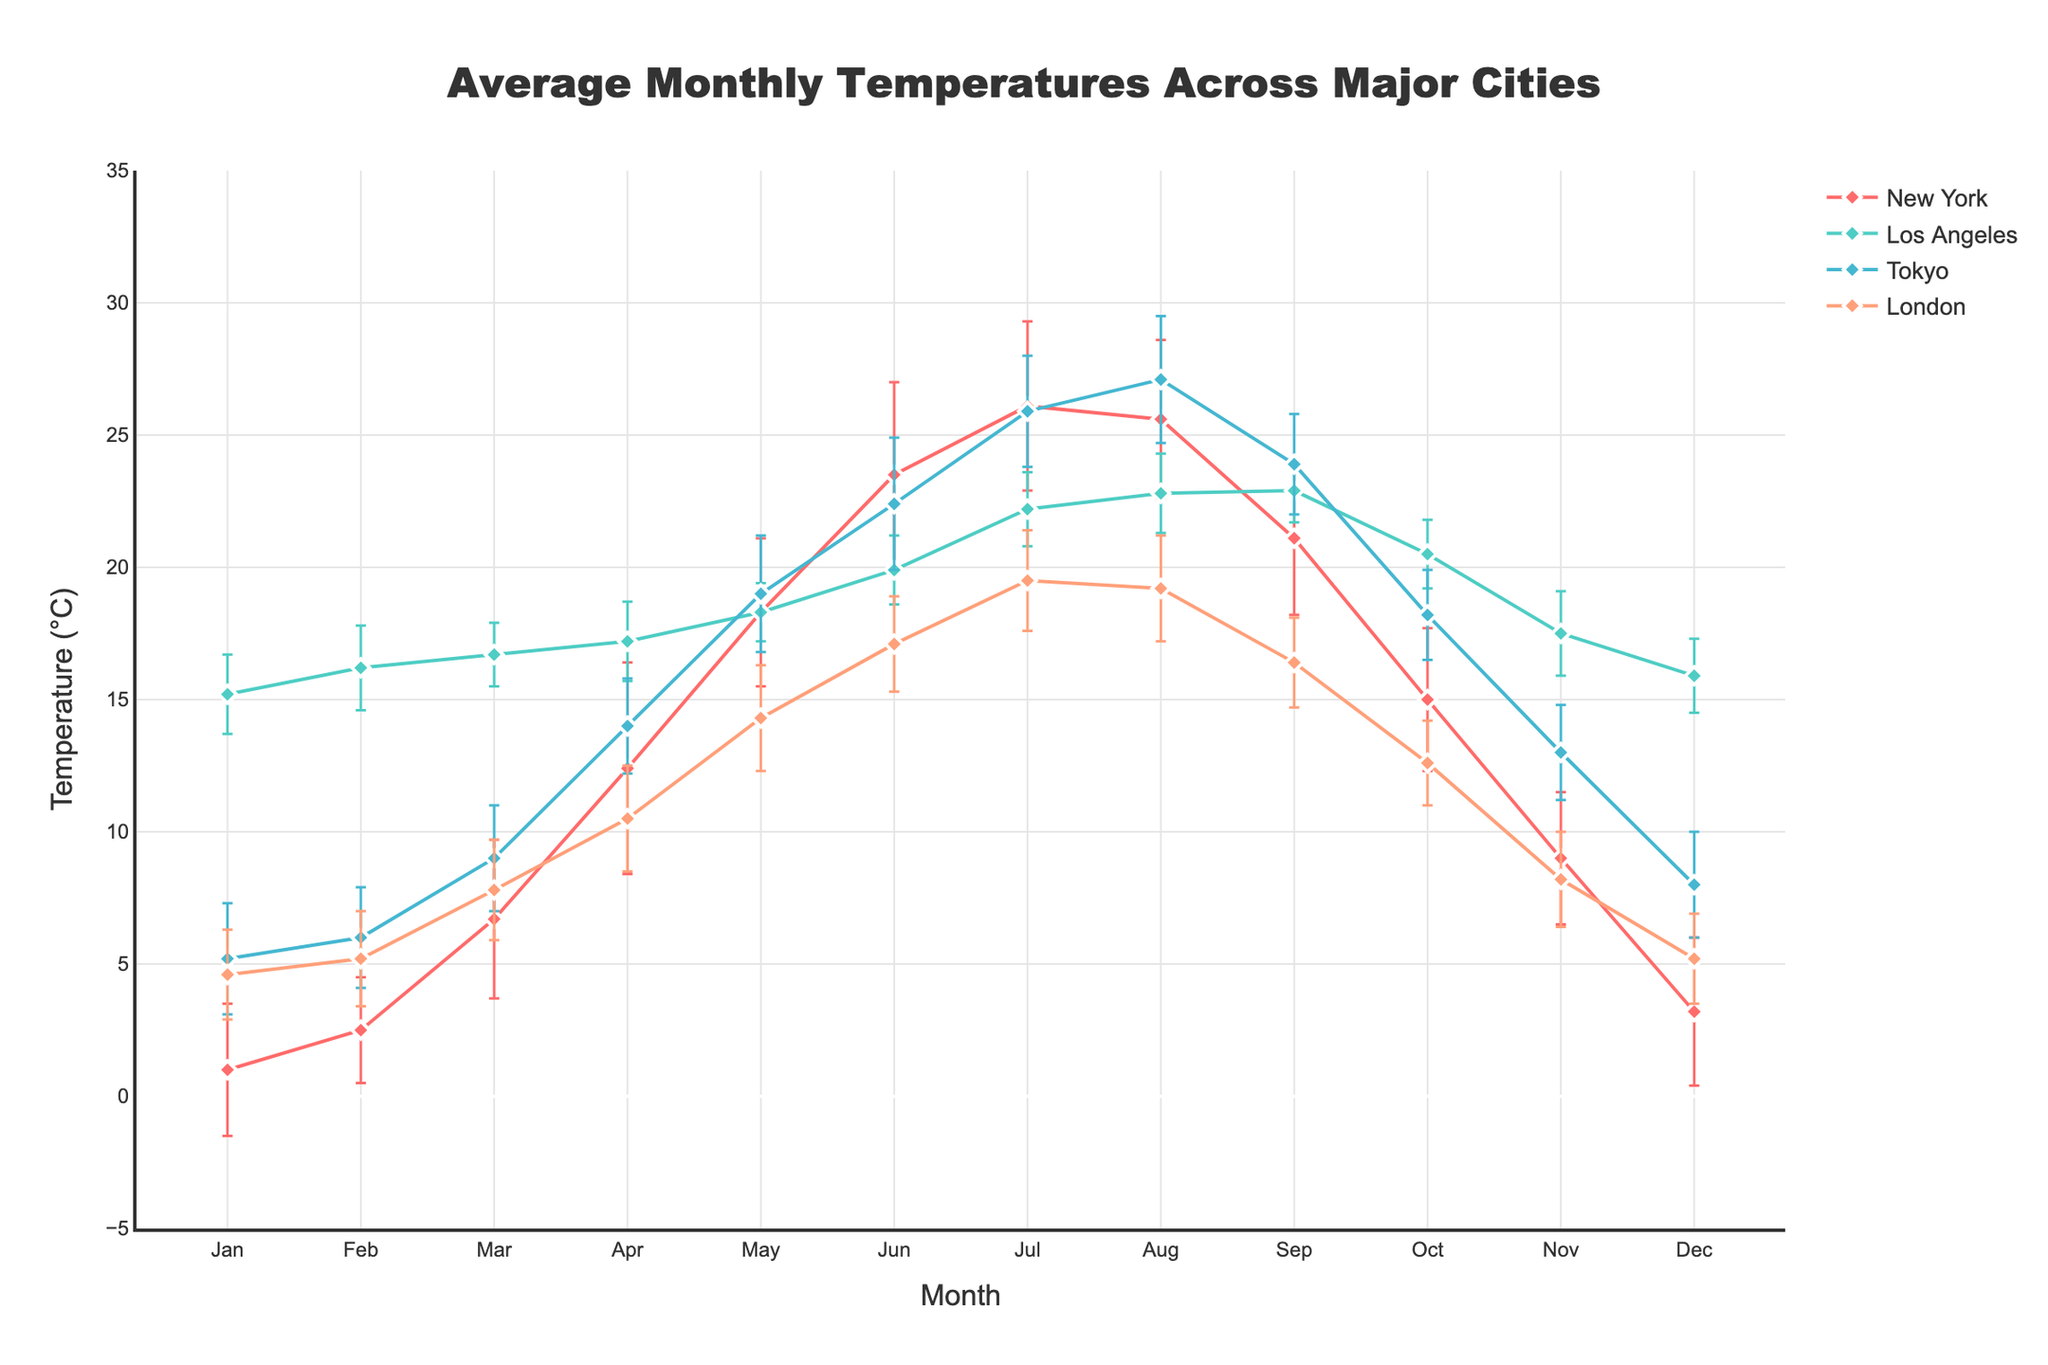What's the title of the figure? The title is prominently displayed at the top center of the figure. It reads 'Average Monthly Temperatures Across Major Cities'.
Answer: Average Monthly Temperatures Across Major Cities How many cities are compared in the figure? Each city's data is represented by a distinct line with markers in the figure. By counting them, we can see there are four cities.
Answer: 4 Which city has the highest average temperature in July? In the month of July, we need to observe the peak values on the y-axis. By doing so, it is evident that Tokyo has the highest average temperature.
Answer: Tokyo What is the approximate temperature range for New York in April? The average temperature for New York in April is 12.4°C, and the error bars indicate a standard deviation of 4.0. Thus, the range is approximately from 12.4 - 4.0 to 12.4 + 4.0.
Answer: 8.4°C to 16.4°C In which month does Los Angeles have the smallest variation in temperature? By examining the error bars, we can see that in May, Los Angeles has the smallest error bar, indicating the smallest variation.
Answer: May How do the average temperatures of London and Tokyo compare in December? Looking at the December data points, the average temperature in London is 5.2°C, and in Tokyo, it is 8.0°C. So, Tokyo is warmer.
Answer: Tokyo is warmer Which city shows the largest range of temperatures throughout the year? By comparing the amplitude of the lines across months, New York has the highest variation from January to December, ranging roughly from 1.0°C to 26.1°C.
Answer: New York What is the difference between the average temperatures for New York and Los Angeles in June? For New York in June, the average temperature is 23.5°C. For Los Angeles in June, it is 19.9°C. The difference is 23.5 - 19.9.
Answer: 3.6°C Which city has the most consistent temperatures throughout the year based on the error bars? By observing the lengths of the error bars for each city, Los Angeles shows the least fluctuation, indicating consistency.
Answer: Los Angeles During which month does Tokyo experience its peak average temperature, and what is the value? Looking at the Tokyo plot line, the highest point is in August with a peak average temperature of 27.1°C.
Answer: August, 27.1°C Compare the average temperature trends of New York and London from January to December. From January to December, New York's temperatures significantly fluctuate, peaking in July. London's temperatures show a more moderate and steady increase, peaking in July and then decreasing.
Answer: New York fluctuates more, London is steadier 